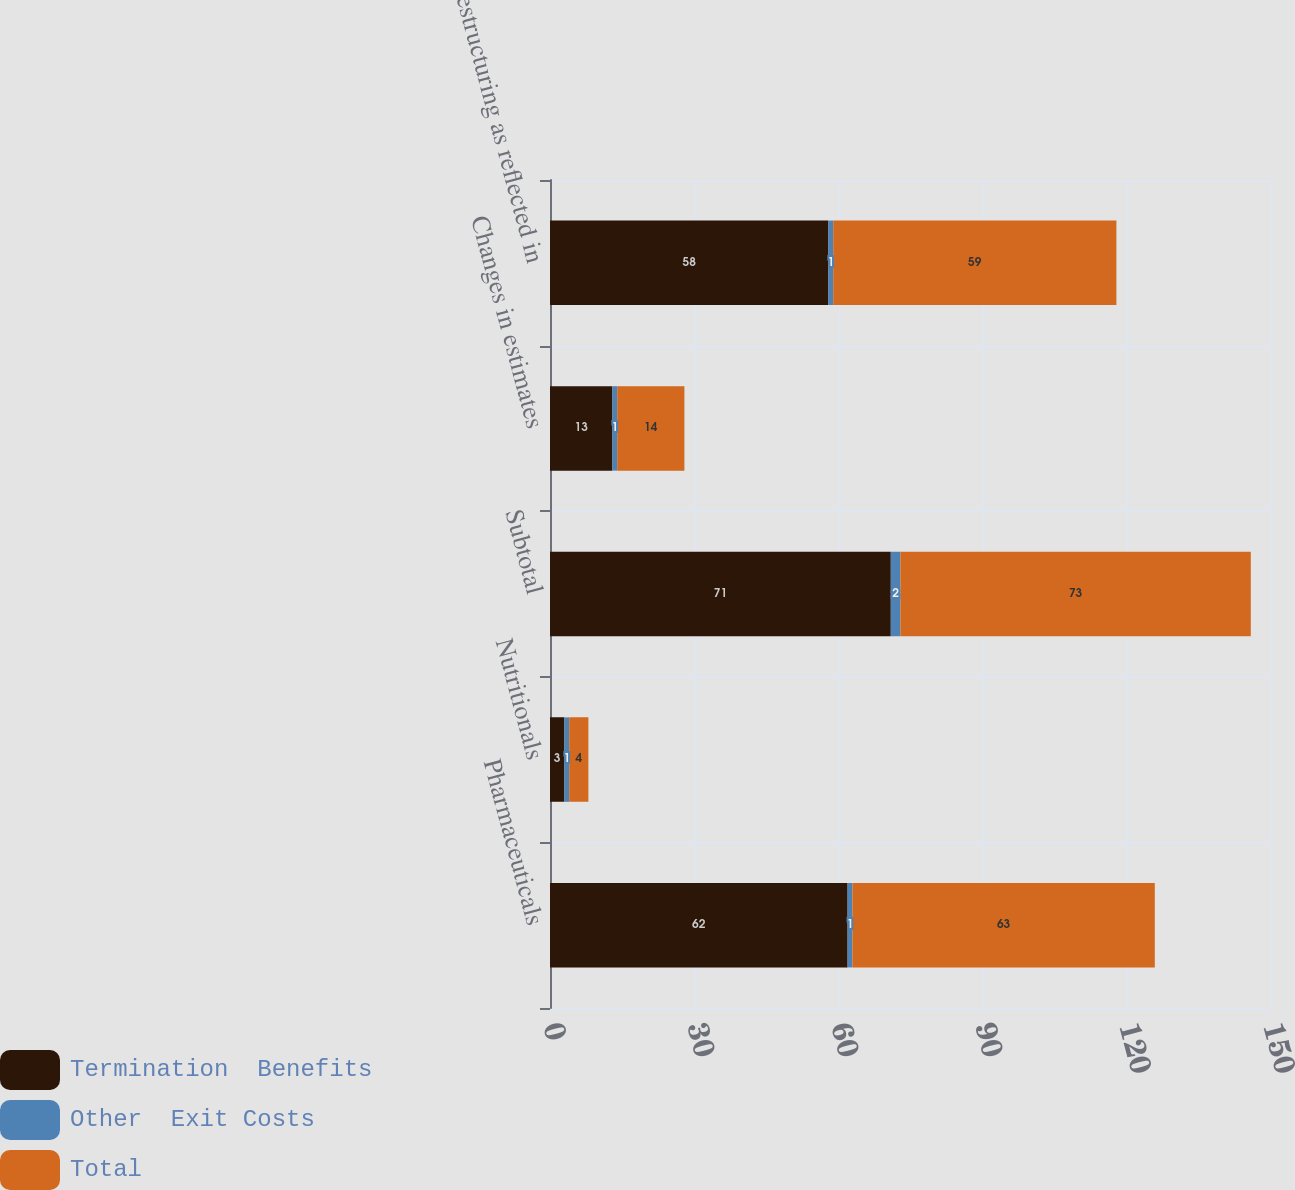<chart> <loc_0><loc_0><loc_500><loc_500><stacked_bar_chart><ecel><fcel>Pharmaceuticals<fcel>Nutritionals<fcel>Subtotal<fcel>Changes in estimates<fcel>Restructuring as reflected in<nl><fcel>Termination  Benefits<fcel>62<fcel>3<fcel>71<fcel>13<fcel>58<nl><fcel>Other  Exit Costs<fcel>1<fcel>1<fcel>2<fcel>1<fcel>1<nl><fcel>Total<fcel>63<fcel>4<fcel>73<fcel>14<fcel>59<nl></chart> 